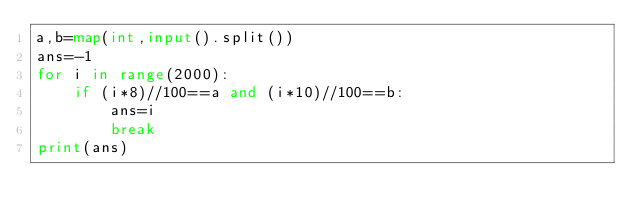Convert code to text. <code><loc_0><loc_0><loc_500><loc_500><_Python_>a,b=map(int,input().split())
ans=-1
for i in range(2000):
    if (i*8)//100==a and (i*10)//100==b:
        ans=i
        break
print(ans)</code> 